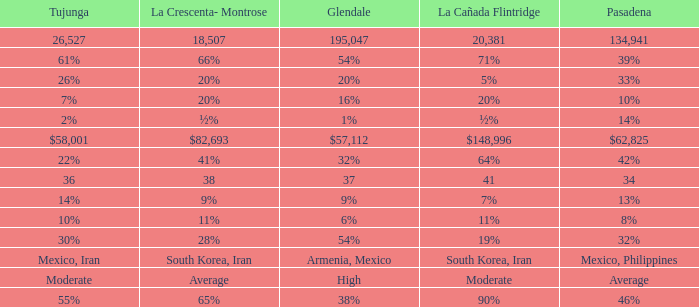What is the figure for Tujunga when Pasadena is 134,941? 26527.0. 